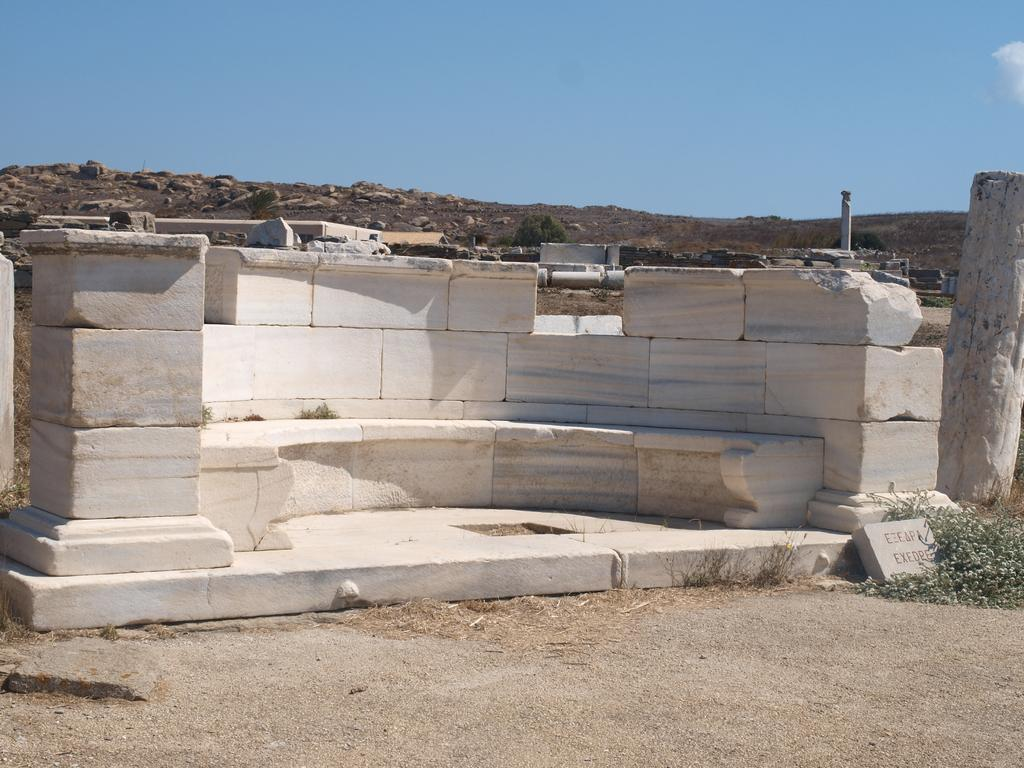What is in the foreground of the image? There is sand in the foreground of the image. What can be seen in the middle of the image? There are marbles in the middle of the image. What is visible at the top of the image? The sky is visible at the top of the image. Can you see the eyes of the person holding the whistle in the image? There is no person holding a whistle present in the image. What type of line is visible in the image? There is no line visible in the image; it features sand, marbles, and the sky. 